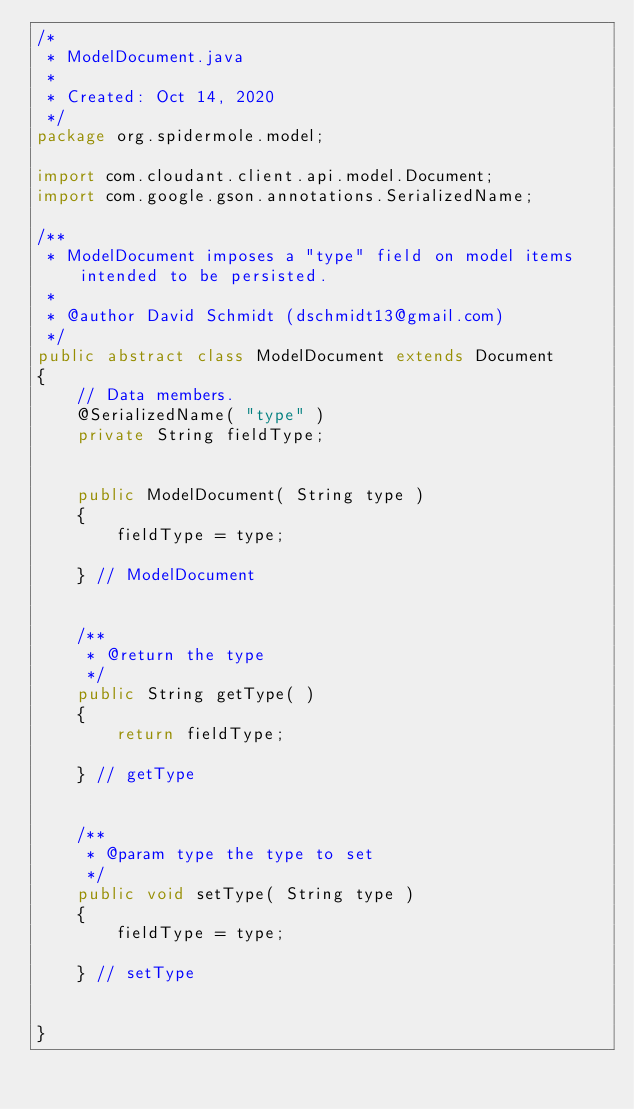Convert code to text. <code><loc_0><loc_0><loc_500><loc_500><_Java_>/*
 * ModelDocument.java
 * 
 * Created: Oct 14, 2020
 */
package org.spidermole.model;

import com.cloudant.client.api.model.Document;
import com.google.gson.annotations.SerializedName;

/**
 * ModelDocument imposes a "type" field on model items intended to be persisted.
 * 
 * @author David Schmidt (dschmidt13@gmail.com)
 */
public abstract class ModelDocument extends Document
{
	// Data members.
	@SerializedName( "type" )
	private String fieldType;


	public ModelDocument( String type )
	{
		fieldType = type;

	} // ModelDocument


	/**
	 * @return the type
	 */
	public String getType( )
	{
		return fieldType;

	} // getType


	/**
	 * @param type the type to set
	 */
	public void setType( String type )
	{
		fieldType = type;

	} // setType


}
</code> 